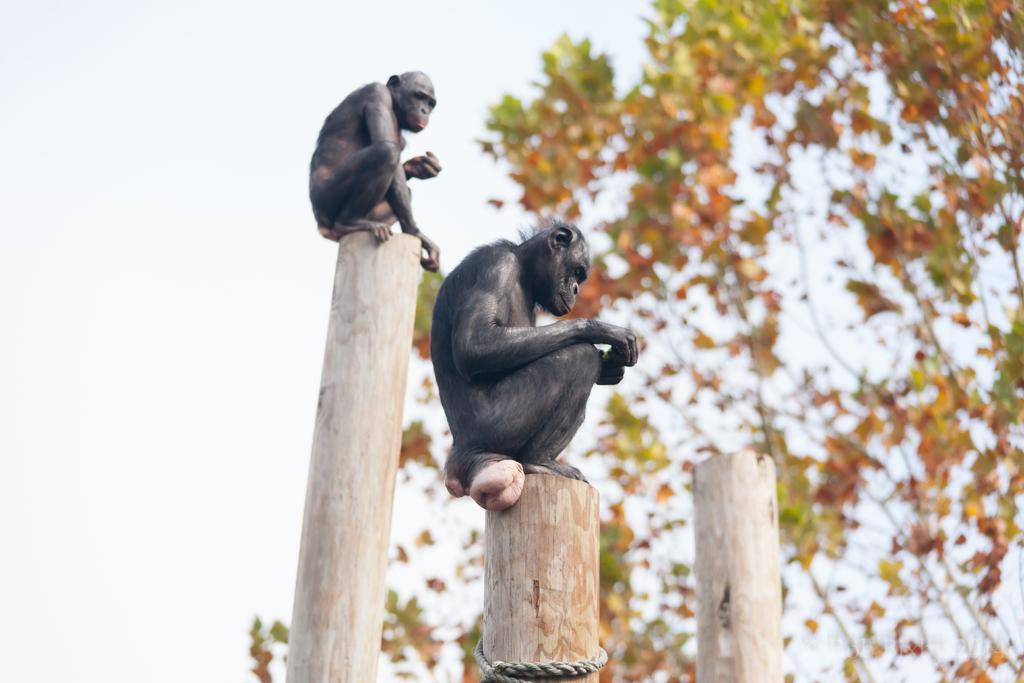In one or two sentences, can you explain what this image depicts? In this image we can see two monkeys are sitting on the wooden poles and there is a rope tied to one of the pole. In the background there is a wooden pole, tree and sky. 